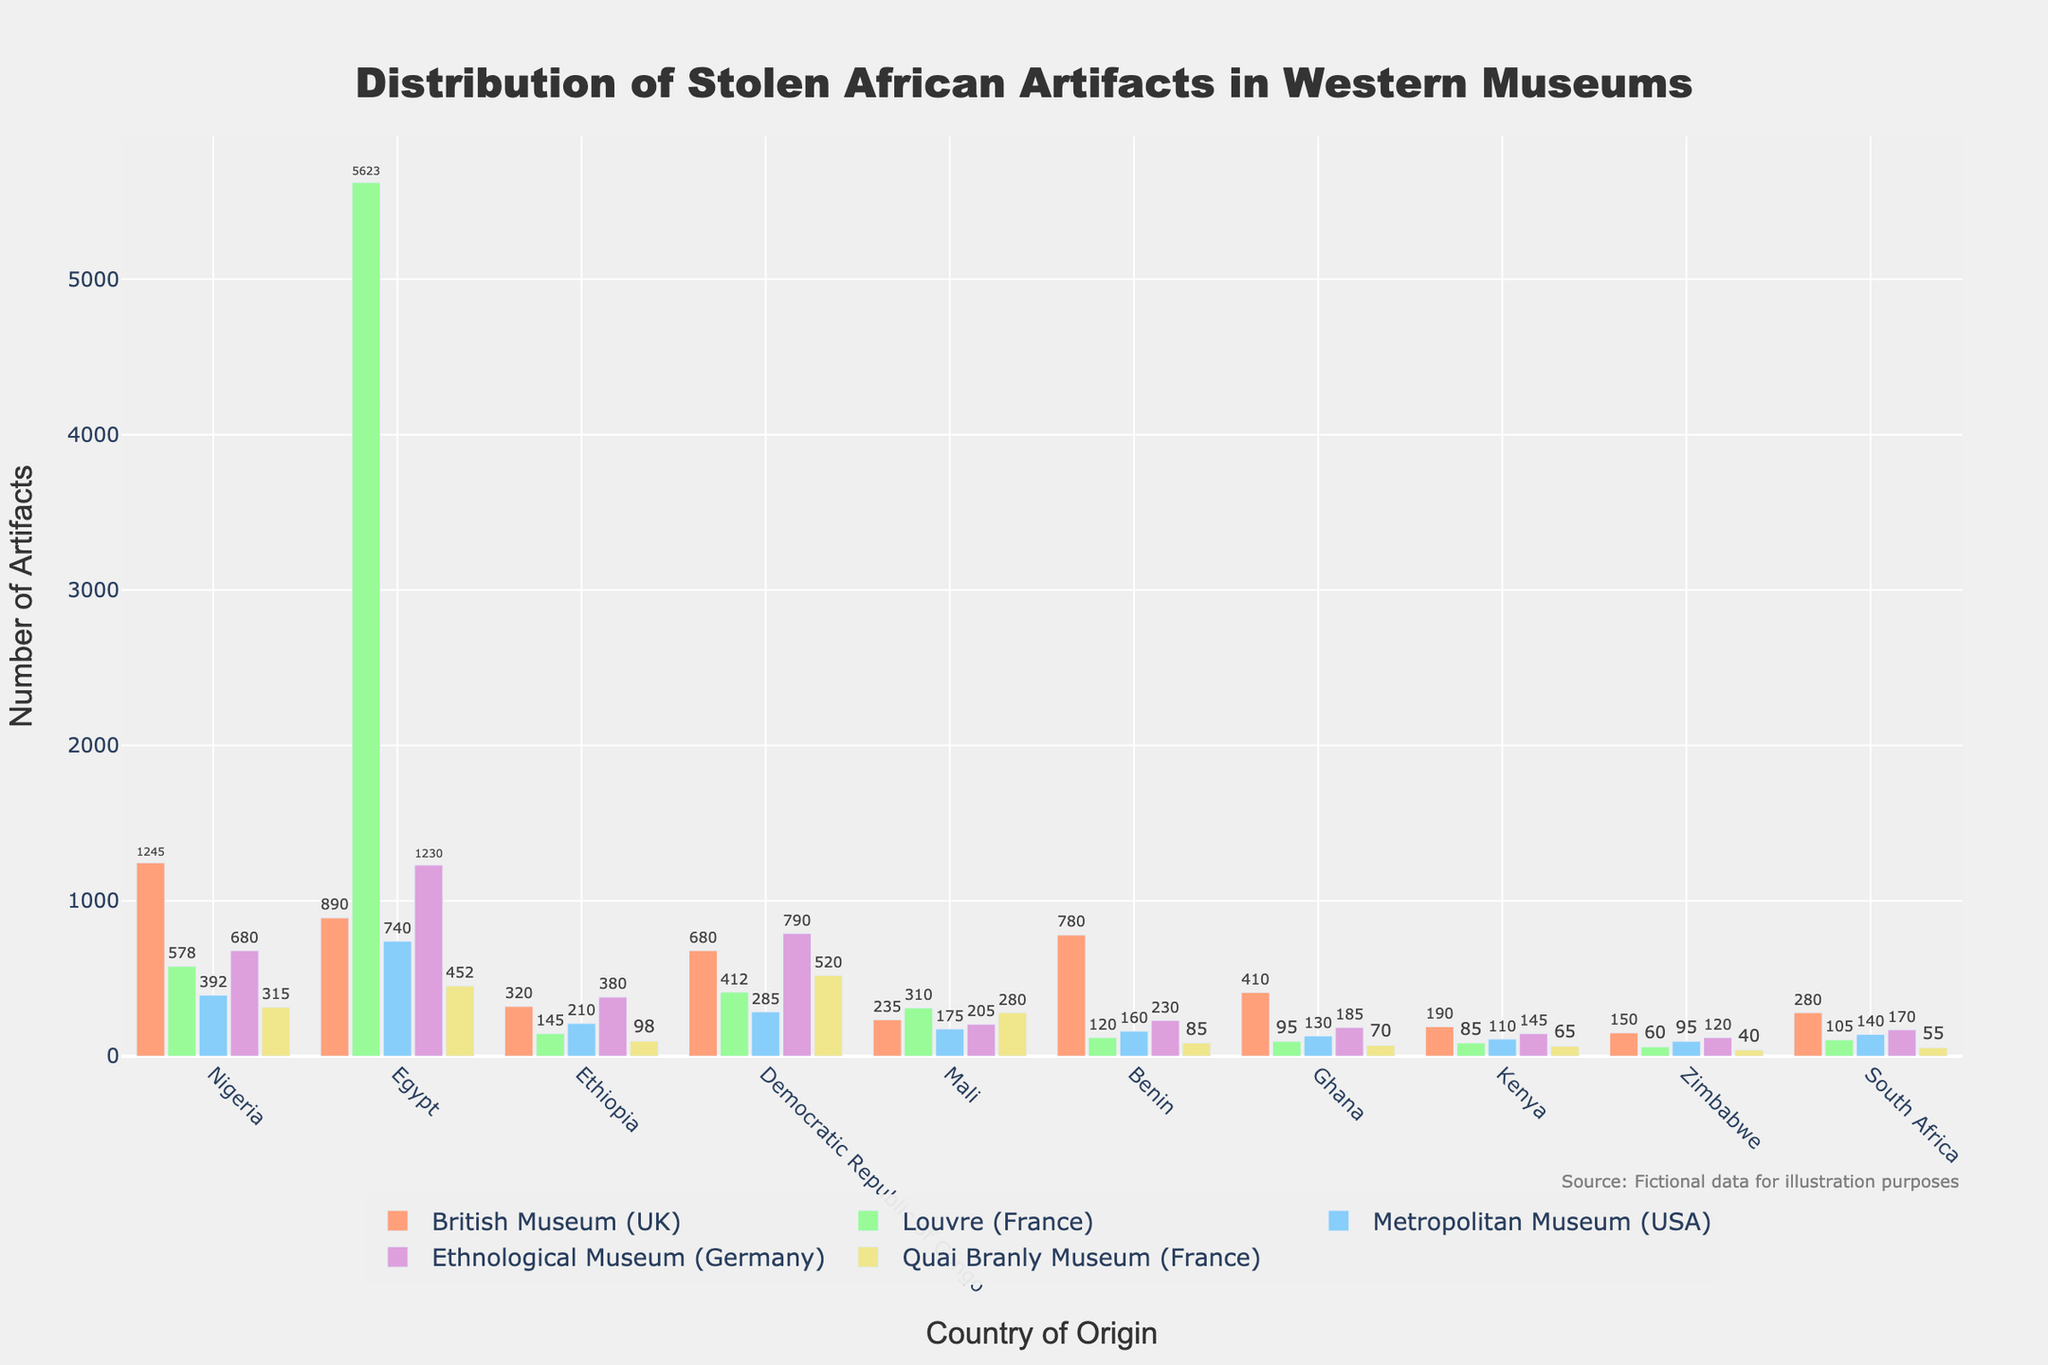How many artifacts from Nigeria are in the British Museum compared to the Metropolitan Museum? The figure shows the number of artifacts from Nigeria in the British Museum as 1245 and in the Metropolitan Museum as 392. To find the difference, subtract the number in the Metropolitan Museum from the number in the British Museum: 1245 - 392 = 853.
Answer: 853 Which museum has the most Egyptian artifacts? The figure shows the number of Egyptian artifacts in each museum. The Louvre (France) has the highest number, with 5623 artifacts.
Answer: Louvre (France) What is the total number of Yoruba artifacts across all the listed museums? The Nigerian artifacts include Yoruba artifacts. Sum the Nigerian artifacts from all the museums: 1245 (British Museum) + 578 (Louvre) + 392 (Metropolitan Museum) + 680 (Ethnological Museum) + 315 (Quai Branly Museum) = 3210.
Answer: 3210 Which country has the least number of artifacts in the Metropolitan Museum? The figure indicates that Zimbabwe has the least number of artifacts in the Metropolitan Museum, with a count of 95.
Answer: Zimbabwe How many more artifacts from the Democratic Republic of Congo are in the Ethnological Museum compared to the Quai Branly Museum? The figure shows that there are 790 artifacts from the Democratic Republic of Congo in the Ethnological Museum and 520 in the Quai Branly Museum. Subtract the number in the Quai Branly Museum from the number in the Ethnological Museum: 790 - 520 = 270.
Answer: 270 What is the average number of artifacts from Egypt across the five museums? The figure shows the number of Egyptian artifacts in each museum: 890 (British Museum), 5623 (Louvre), 740 (Metropolitan Museum), 1230 (Ethnological Museum), 452 (Quai Branly Museum). Sum these values: 890 + 5623 + 740 + 1230 + 452 = 8935. Divide by 5 (number of museums): 8935 / 5 = 1787.
Answer: 1787 Which museum has the smallest collection of South African artifacts? The figure shows the number of South African artifacts in each museum. The Quai Branly Museum (France) has the smallest collection, with 55 artifacts.
Answer: Quai Branly Museum (France) What is the total number of Malian and Ghanaian artifacts in the British Museum? The figure shows 235 Malian artifacts and 410 Ghanaian artifacts in the British Museum. Sum these values: 235 + 410 = 645.
Answer: 645 